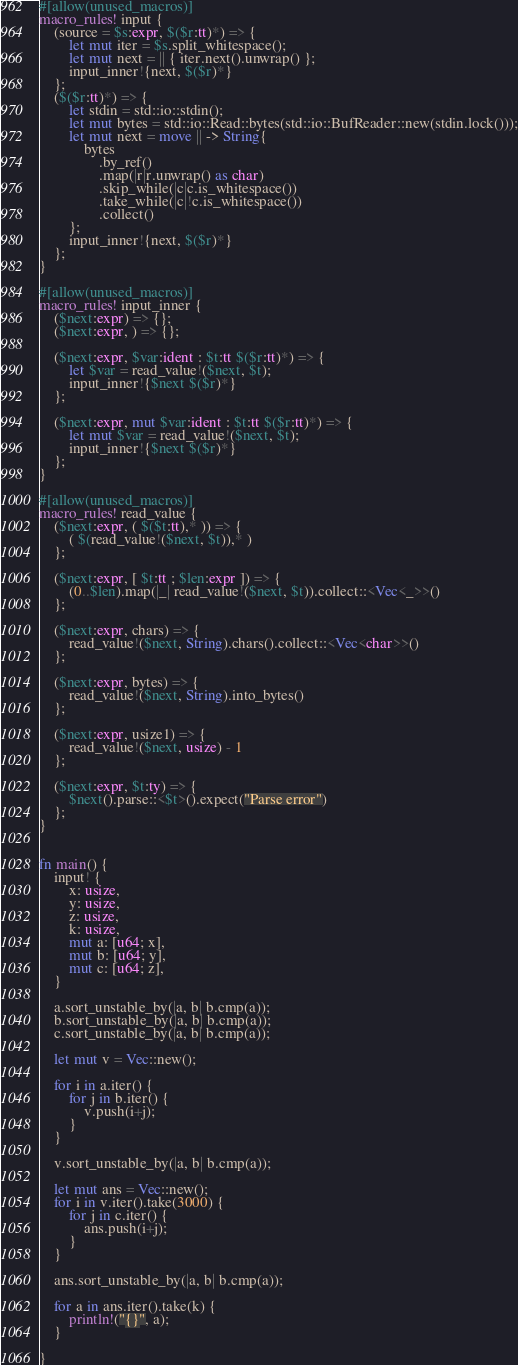<code> <loc_0><loc_0><loc_500><loc_500><_Rust_>#[allow(unused_macros)]
macro_rules! input {
    (source = $s:expr, $($r:tt)*) => {
        let mut iter = $s.split_whitespace();
        let mut next = || { iter.next().unwrap() };
        input_inner!{next, $($r)*}
    };
    ($($r:tt)*) => {
        let stdin = std::io::stdin();
        let mut bytes = std::io::Read::bytes(std::io::BufReader::new(stdin.lock()));
        let mut next = move || -> String{
            bytes
                .by_ref()
                .map(|r|r.unwrap() as char)
                .skip_while(|c|c.is_whitespace())
                .take_while(|c|!c.is_whitespace())
                .collect()
        };
        input_inner!{next, $($r)*}
    };
}
 
#[allow(unused_macros)]
macro_rules! input_inner {
    ($next:expr) => {};
    ($next:expr, ) => {};
 
    ($next:expr, $var:ident : $t:tt $($r:tt)*) => {
        let $var = read_value!($next, $t);
        input_inner!{$next $($r)*}
    };
 
    ($next:expr, mut $var:ident : $t:tt $($r:tt)*) => {
        let mut $var = read_value!($next, $t);
        input_inner!{$next $($r)*}
    };
}
 
#[allow(unused_macros)]
macro_rules! read_value {
    ($next:expr, ( $($t:tt),* )) => {
        ( $(read_value!($next, $t)),* )
    };
 
    ($next:expr, [ $t:tt ; $len:expr ]) => {
        (0..$len).map(|_| read_value!($next, $t)).collect::<Vec<_>>()
    };
 
    ($next:expr, chars) => {
        read_value!($next, String).chars().collect::<Vec<char>>()
    };
 
    ($next:expr, bytes) => {
        read_value!($next, String).into_bytes()
    };
 
    ($next:expr, usize1) => {
        read_value!($next, usize) - 1
    };
 
    ($next:expr, $t:ty) => {
        $next().parse::<$t>().expect("Parse error")
    };
}


fn main() {
    input! {
        x: usize,
        y: usize,
        z: usize,
        k: usize,
        mut a: [u64; x],
        mut b: [u64; y],
        mut c: [u64; z],
    }

    a.sort_unstable_by(|a, b| b.cmp(a));
    b.sort_unstable_by(|a, b| b.cmp(a));
    c.sort_unstable_by(|a, b| b.cmp(a));

    let mut v = Vec::new();

    for i in a.iter() {
        for j in b.iter() {
            v.push(i+j);
        }
    }

    v.sort_unstable_by(|a, b| b.cmp(a));

    let mut ans = Vec::new();
    for i in v.iter().take(3000) {
        for j in c.iter() {
            ans.push(i+j);
        }
    }

    ans.sort_unstable_by(|a, b| b.cmp(a));

    for a in ans.iter().take(k) {
        println!("{}", a);
    }
    
}
</code> 